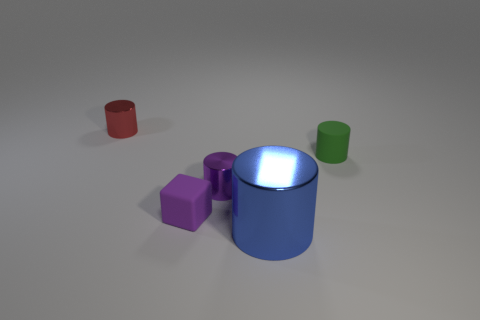Subtract all large blue shiny cylinders. How many cylinders are left? 3 Subtract 1 cylinders. How many cylinders are left? 3 Subtract all purple cylinders. How many cylinders are left? 3 Add 2 big green matte blocks. How many objects exist? 7 Subtract all cubes. How many objects are left? 4 Subtract all green cylinders. Subtract all green blocks. How many cylinders are left? 3 Add 5 small red cylinders. How many small red cylinders are left? 6 Add 4 large blue matte blocks. How many large blue matte blocks exist? 4 Subtract 0 brown balls. How many objects are left? 5 Subtract all green rubber objects. Subtract all tiny gray shiny spheres. How many objects are left? 4 